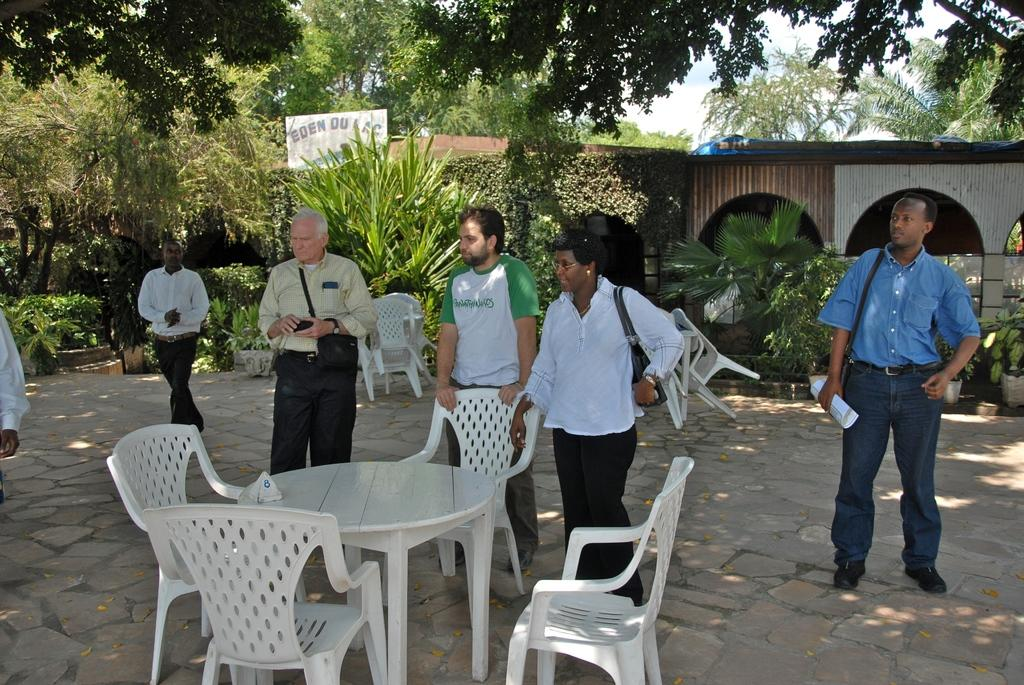What type of natural elements can be seen in the background of the image? There are trees and plants in the background of the image. What objects are present in the background of the image? There are empty chairs in the background of the image. What position are the persons in the image? All the persons are standing in the image. Can you see any ghosts or hooks in the image? No, there are no ghosts or hooks present in the image. 